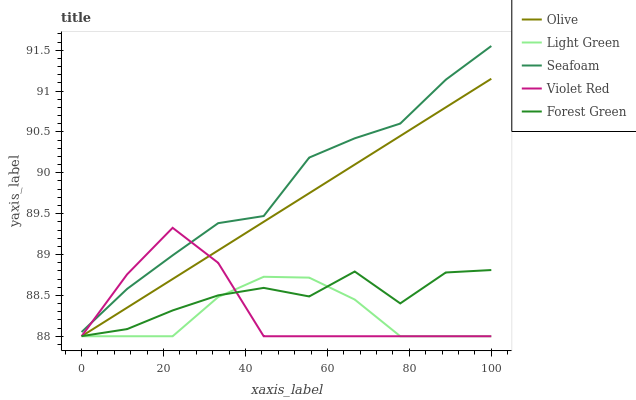Does Light Green have the minimum area under the curve?
Answer yes or no. Yes. Does Seafoam have the maximum area under the curve?
Answer yes or no. Yes. Does Violet Red have the minimum area under the curve?
Answer yes or no. No. Does Violet Red have the maximum area under the curve?
Answer yes or no. No. Is Olive the smoothest?
Answer yes or no. Yes. Is Forest Green the roughest?
Answer yes or no. Yes. Is Violet Red the smoothest?
Answer yes or no. No. Is Violet Red the roughest?
Answer yes or no. No. Does Olive have the lowest value?
Answer yes or no. Yes. Does Seafoam have the lowest value?
Answer yes or no. No. Does Seafoam have the highest value?
Answer yes or no. Yes. Does Violet Red have the highest value?
Answer yes or no. No. Is Forest Green less than Seafoam?
Answer yes or no. Yes. Is Seafoam greater than Forest Green?
Answer yes or no. Yes. Does Light Green intersect Forest Green?
Answer yes or no. Yes. Is Light Green less than Forest Green?
Answer yes or no. No. Is Light Green greater than Forest Green?
Answer yes or no. No. Does Forest Green intersect Seafoam?
Answer yes or no. No. 